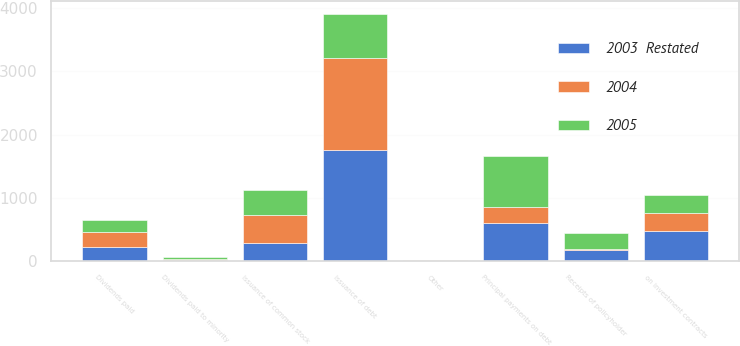Convert chart to OTSL. <chart><loc_0><loc_0><loc_500><loc_500><stacked_bar_chart><ecel><fcel>Dividends paid<fcel>Dividends paid to minority<fcel>Issuance of common stock<fcel>Principal payments on debt<fcel>Issuance of debt<fcel>Receipts of policyholder<fcel>on investment contracts<fcel>Other<nl><fcel>2004<fcel>239.9<fcel>22<fcel>432.5<fcel>250.5<fcel>1460.1<fcel>6.6<fcel>281.2<fcel>5.6<nl><fcel>2003  Restated<fcel>216.8<fcel>14.8<fcel>287.8<fcel>606<fcel>1747.9<fcel>180.8<fcel>479.4<fcel>6.5<nl><fcel>2005<fcel>191.8<fcel>26.4<fcel>399.7<fcel>807.5<fcel>706.4<fcel>250.5<fcel>288.3<fcel>3.8<nl></chart> 